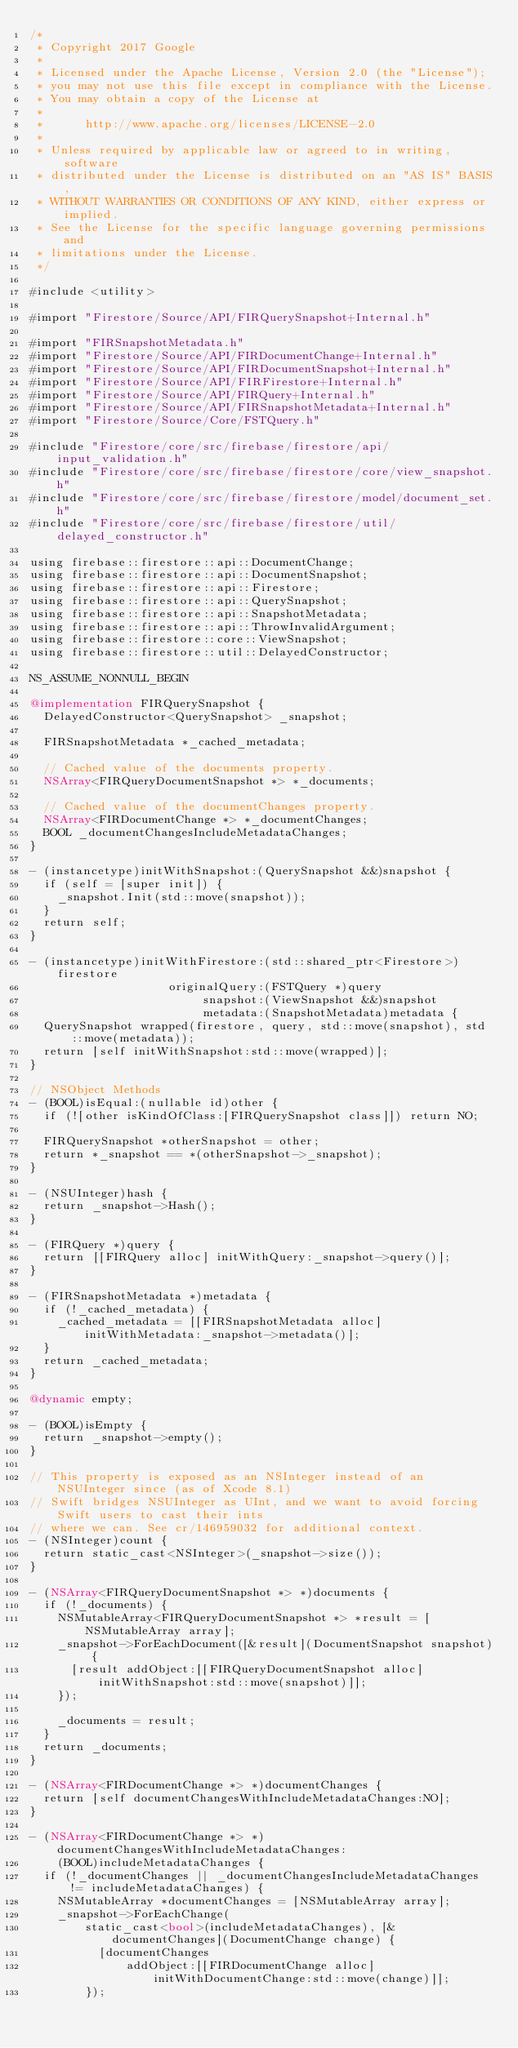<code> <loc_0><loc_0><loc_500><loc_500><_ObjectiveC_>/*
 * Copyright 2017 Google
 *
 * Licensed under the Apache License, Version 2.0 (the "License");
 * you may not use this file except in compliance with the License.
 * You may obtain a copy of the License at
 *
 *      http://www.apache.org/licenses/LICENSE-2.0
 *
 * Unless required by applicable law or agreed to in writing, software
 * distributed under the License is distributed on an "AS IS" BASIS,
 * WITHOUT WARRANTIES OR CONDITIONS OF ANY KIND, either express or implied.
 * See the License for the specific language governing permissions and
 * limitations under the License.
 */

#include <utility>

#import "Firestore/Source/API/FIRQuerySnapshot+Internal.h"

#import "FIRSnapshotMetadata.h"
#import "Firestore/Source/API/FIRDocumentChange+Internal.h"
#import "Firestore/Source/API/FIRDocumentSnapshot+Internal.h"
#import "Firestore/Source/API/FIRFirestore+Internal.h"
#import "Firestore/Source/API/FIRQuery+Internal.h"
#import "Firestore/Source/API/FIRSnapshotMetadata+Internal.h"
#import "Firestore/Source/Core/FSTQuery.h"

#include "Firestore/core/src/firebase/firestore/api/input_validation.h"
#include "Firestore/core/src/firebase/firestore/core/view_snapshot.h"
#include "Firestore/core/src/firebase/firestore/model/document_set.h"
#include "Firestore/core/src/firebase/firestore/util/delayed_constructor.h"

using firebase::firestore::api::DocumentChange;
using firebase::firestore::api::DocumentSnapshot;
using firebase::firestore::api::Firestore;
using firebase::firestore::api::QuerySnapshot;
using firebase::firestore::api::SnapshotMetadata;
using firebase::firestore::api::ThrowInvalidArgument;
using firebase::firestore::core::ViewSnapshot;
using firebase::firestore::util::DelayedConstructor;

NS_ASSUME_NONNULL_BEGIN

@implementation FIRQuerySnapshot {
  DelayedConstructor<QuerySnapshot> _snapshot;

  FIRSnapshotMetadata *_cached_metadata;

  // Cached value of the documents property.
  NSArray<FIRQueryDocumentSnapshot *> *_documents;

  // Cached value of the documentChanges property.
  NSArray<FIRDocumentChange *> *_documentChanges;
  BOOL _documentChangesIncludeMetadataChanges;
}

- (instancetype)initWithSnapshot:(QuerySnapshot &&)snapshot {
  if (self = [super init]) {
    _snapshot.Init(std::move(snapshot));
  }
  return self;
}

- (instancetype)initWithFirestore:(std::shared_ptr<Firestore>)firestore
                    originalQuery:(FSTQuery *)query
                         snapshot:(ViewSnapshot &&)snapshot
                         metadata:(SnapshotMetadata)metadata {
  QuerySnapshot wrapped(firestore, query, std::move(snapshot), std::move(metadata));
  return [self initWithSnapshot:std::move(wrapped)];
}

// NSObject Methods
- (BOOL)isEqual:(nullable id)other {
  if (![other isKindOfClass:[FIRQuerySnapshot class]]) return NO;

  FIRQuerySnapshot *otherSnapshot = other;
  return *_snapshot == *(otherSnapshot->_snapshot);
}

- (NSUInteger)hash {
  return _snapshot->Hash();
}

- (FIRQuery *)query {
  return [[FIRQuery alloc] initWithQuery:_snapshot->query()];
}

- (FIRSnapshotMetadata *)metadata {
  if (!_cached_metadata) {
    _cached_metadata = [[FIRSnapshotMetadata alloc] initWithMetadata:_snapshot->metadata()];
  }
  return _cached_metadata;
}

@dynamic empty;

- (BOOL)isEmpty {
  return _snapshot->empty();
}

// This property is exposed as an NSInteger instead of an NSUInteger since (as of Xcode 8.1)
// Swift bridges NSUInteger as UInt, and we want to avoid forcing Swift users to cast their ints
// where we can. See cr/146959032 for additional context.
- (NSInteger)count {
  return static_cast<NSInteger>(_snapshot->size());
}

- (NSArray<FIRQueryDocumentSnapshot *> *)documents {
  if (!_documents) {
    NSMutableArray<FIRQueryDocumentSnapshot *> *result = [NSMutableArray array];
    _snapshot->ForEachDocument([&result](DocumentSnapshot snapshot) {
      [result addObject:[[FIRQueryDocumentSnapshot alloc] initWithSnapshot:std::move(snapshot)]];
    });

    _documents = result;
  }
  return _documents;
}

- (NSArray<FIRDocumentChange *> *)documentChanges {
  return [self documentChangesWithIncludeMetadataChanges:NO];
}

- (NSArray<FIRDocumentChange *> *)documentChangesWithIncludeMetadataChanges:
    (BOOL)includeMetadataChanges {
  if (!_documentChanges || _documentChangesIncludeMetadataChanges != includeMetadataChanges) {
    NSMutableArray *documentChanges = [NSMutableArray array];
    _snapshot->ForEachChange(
        static_cast<bool>(includeMetadataChanges), [&documentChanges](DocumentChange change) {
          [documentChanges
              addObject:[[FIRDocumentChange alloc] initWithDocumentChange:std::move(change)]];
        });
</code> 